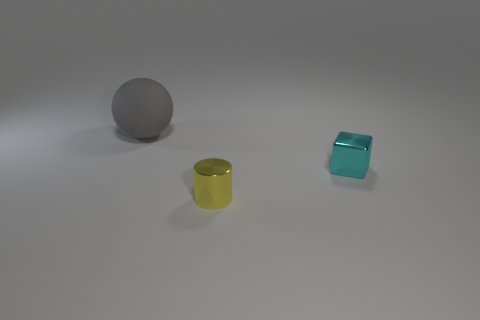Add 3 big gray balls. How many objects exist? 6 Subtract all cylinders. How many objects are left? 2 Add 3 green matte blocks. How many green matte blocks exist? 3 Subtract 0 green cubes. How many objects are left? 3 Subtract all big blue things. Subtract all large balls. How many objects are left? 2 Add 2 tiny cyan metal objects. How many tiny cyan metal objects are left? 3 